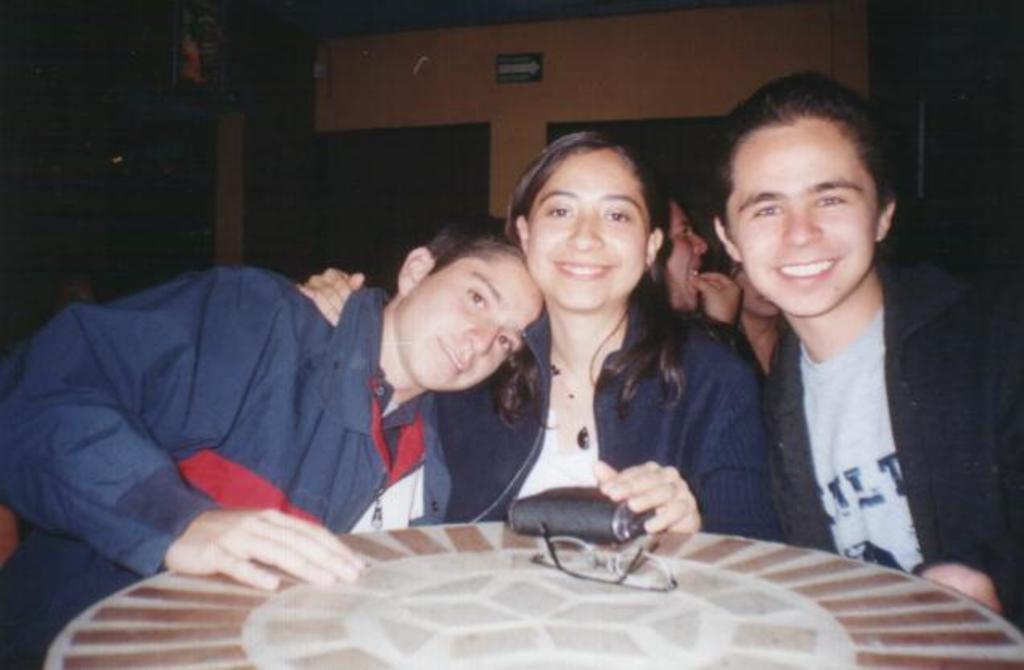In one or two sentences, can you explain what this image depicts? In this image I can see few people and I can also see smile on their faces. 